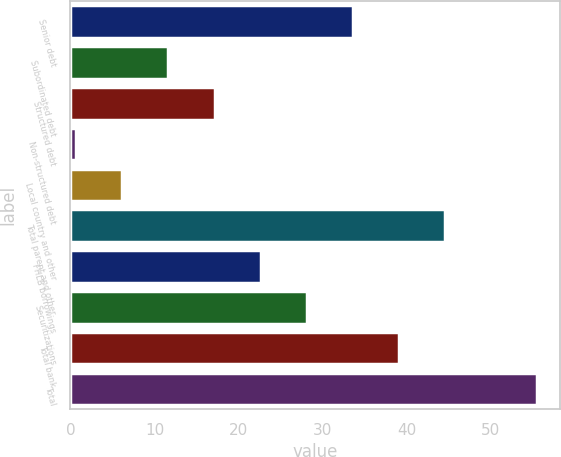Convert chart to OTSL. <chart><loc_0><loc_0><loc_500><loc_500><bar_chart><fcel>Senior debt<fcel>Subordinated debt<fcel>Structured debt<fcel>Non-structured debt<fcel>Local country and other<fcel>Total parent and other<fcel>FHLB borrowings<fcel>Securitizations<fcel>Total bank<fcel>Total<nl><fcel>33.58<fcel>11.66<fcel>17.14<fcel>0.7<fcel>6.18<fcel>44.54<fcel>22.62<fcel>28.1<fcel>39.06<fcel>55.5<nl></chart> 